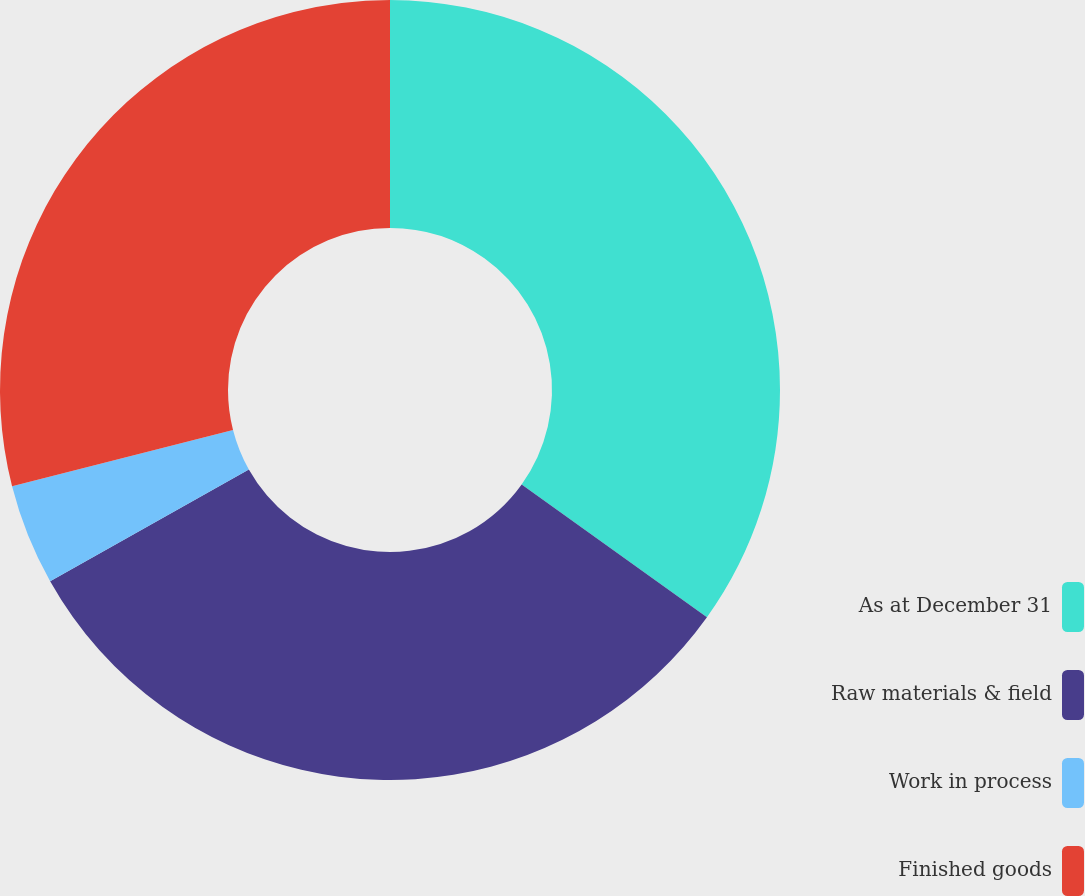Convert chart. <chart><loc_0><loc_0><loc_500><loc_500><pie_chart><fcel>As at December 31<fcel>Raw materials & field<fcel>Work in process<fcel>Finished goods<nl><fcel>34.9%<fcel>31.94%<fcel>4.19%<fcel>28.97%<nl></chart> 